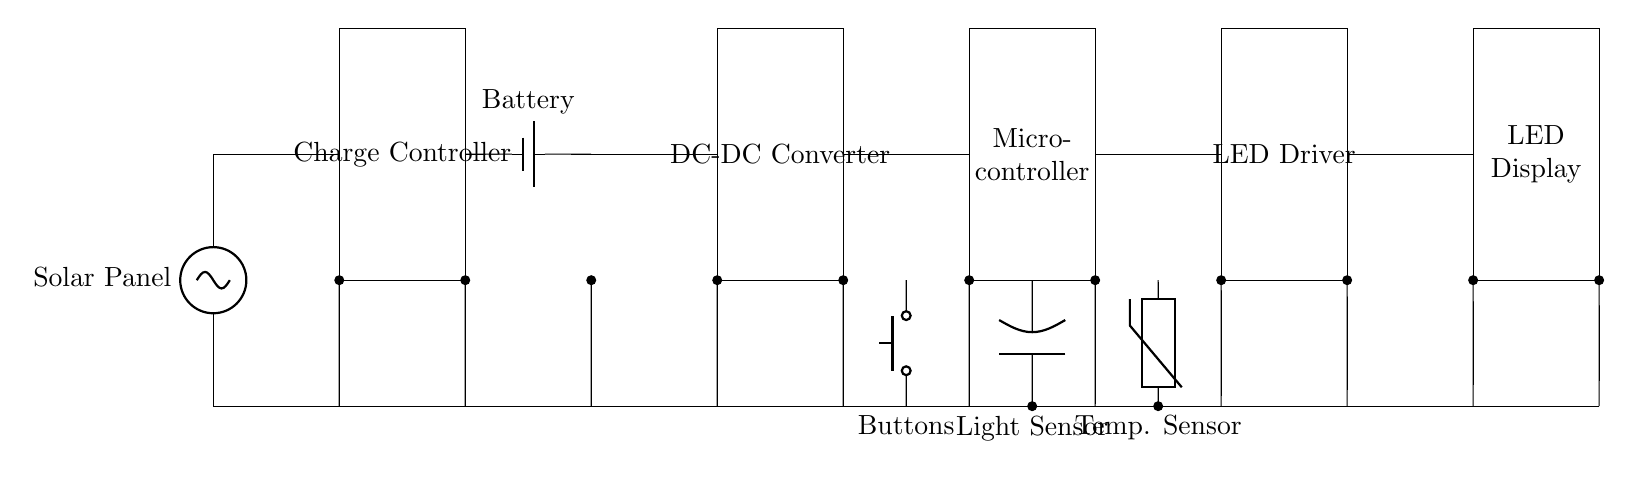What is the main power source for this circuit? The main power source is the solar panel, which is indicated at the beginning of the circuit diagram.
Answer: Solar panel What type of components can be found in the circuit diagram? The circuit includes components like a charge controller, battery, DC-DC converter, microcontroller, LED driver, LED display, light sensor, temperature sensor, and buttons, all labeled in the diagram.
Answer: Charge controller, battery, DC-DC converter, microcontroller, LED driver, LED display, light sensor, temperature sensor, buttons What does the light sensor do in this circuit? The light sensor measures ambient light levels, which influences the operation of the LED display to optimize visibility based on environmental conditions.
Answer: Measures ambient light levels How many sensors are present in the circuit? There are two sensors present: a light sensor and a temperature sensor, each represented in the diagram below the microcontroller.
Answer: Two What is the purpose of the DC-DC converter in this circuit? The DC-DC converter steps up or down the voltage from the battery to the required level for the microcontroller and other components, ensuring they operate effectively despite varying battery voltage.
Answer: Voltage adjustment Which component drives the LED display? The LED driver specifically drives the LED display, managing the current and ensuring the display receives the necessary voltage and current for operation.
Answer: LED driver 